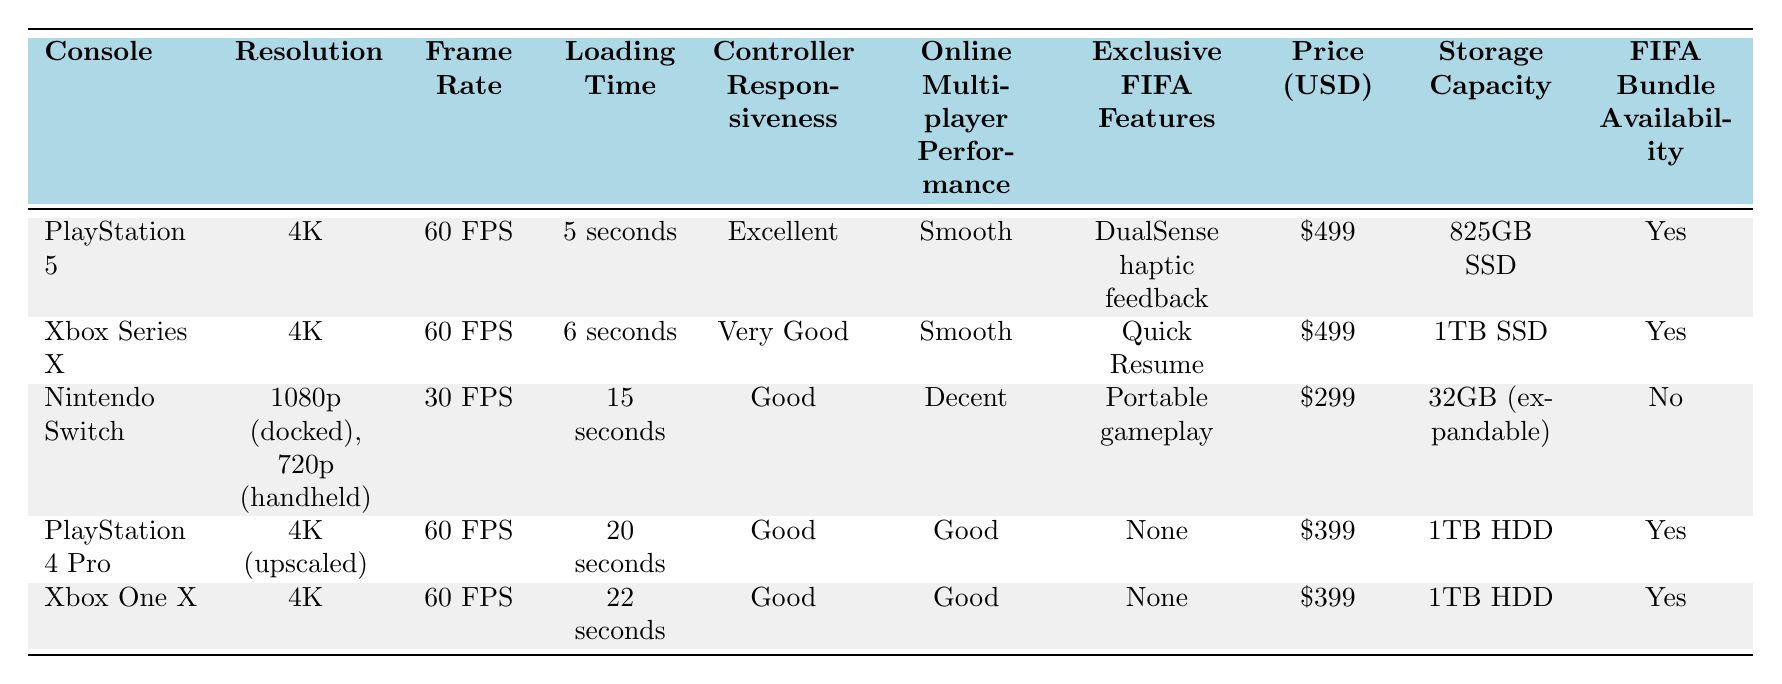What is the loading time for the Xbox Series X? The table states that the loading time for the Xbox Series X is 6 seconds.
Answer: 6 seconds Which console has the lowest price? By comparing the prices listed, the Nintendo Switch is priced at 299 USD, which is lower than the other consoles.
Answer: 299 USD How many consoles have a 4K resolution? From the table, there are four consoles (PlayStation 5, Xbox Series X, PlayStation 4 Pro, and Xbox One X) that support a 4K resolution.
Answer: Four consoles What feature does the PlayStation 5 offer that is exclusive to FIFA? The PlayStation 5 has DualSense haptic feedback as its exclusive FIFA feature according to the table.
Answer: DualSense haptic feedback What is the average storage capacity of the consoles listed? The storage capacities are: 825GB, 1TB (1000GB), 32GB, 1TB (1000GB), and 1TB (1000GB). To find the average: (825 + 1000 + 32 + 1000 + 1000) / 5 = 385.4 GB. Therefore, the average storage capacity is approximately 385.4 GB.
Answer: Approximately 385.4 GB Does the Nintendo Switch have any exclusive FIFA features? According to the table, the Nintendo Switch has "Portable gameplay" as its exclusive FIFA feature. Therefore, it does have an exclusive feature.
Answer: Yes Which console has the best online multiplayer performance? The PlayStation 5 and Xbox Series X both have "Smooth" online multiplayer performance, which is better than the other consoles that state "Good" or "Decent".
Answer: PlayStation 5 and Xbox Series X What is the difference in loading times between the PlayStation 4 Pro and the Xbox One X? The loading time for the PlayStation 4 Pro is 20 seconds, while for the Xbox One X it is 22 seconds. The difference is calculated as 22 - 20 = 2 seconds.
Answer: 2 seconds Is there a FIFA bundle available for the Nintendo Switch? The table indicates that the Nintendo Switch does not have FIFA bundle availability listed as "Yes."
Answer: No 